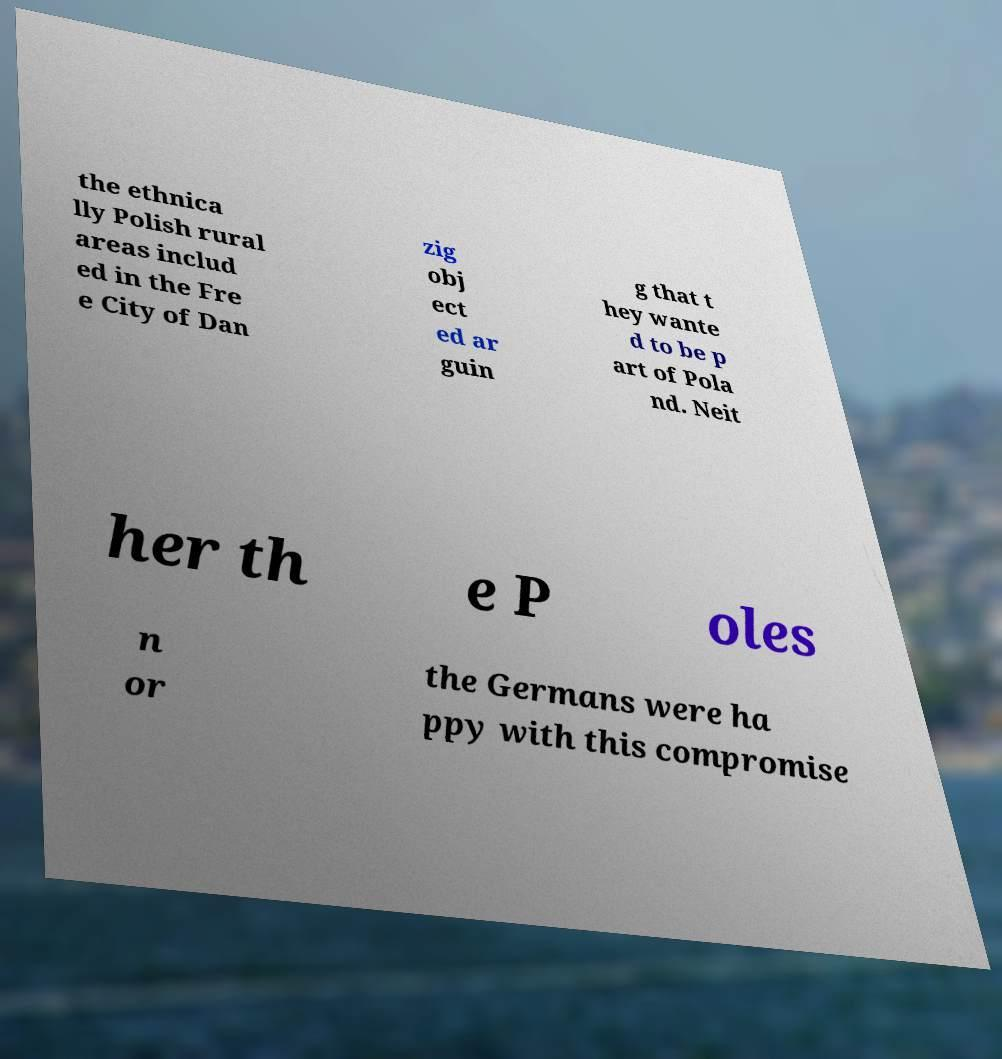Could you assist in decoding the text presented in this image and type it out clearly? the ethnica lly Polish rural areas includ ed in the Fre e City of Dan zig obj ect ed ar guin g that t hey wante d to be p art of Pola nd. Neit her th e P oles n or the Germans were ha ppy with this compromise 